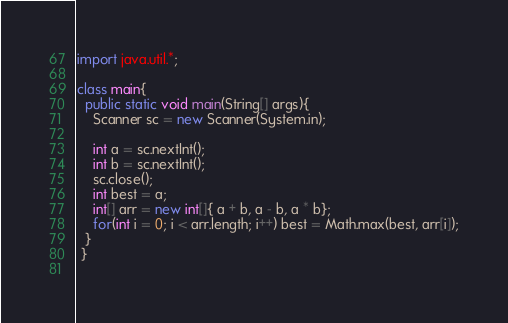Convert code to text. <code><loc_0><loc_0><loc_500><loc_500><_Java_>import java.util.*;

class main{
  public static void main(String[] args){
    Scanner sc = new Scanner(System.in);
    
    int a = sc.nextInt();
    int b = sc.nextInt();
    sc.close();
    int best = a;
    int[] arr = new int[]{ a + b, a - b, a * b};
    for(int i = 0; i < arr.length; i++) best = Math.max(best, arr[i]);
  }
 }
    </code> 